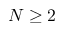<formula> <loc_0><loc_0><loc_500><loc_500>N \geq 2</formula> 